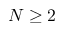<formula> <loc_0><loc_0><loc_500><loc_500>N \geq 2</formula> 